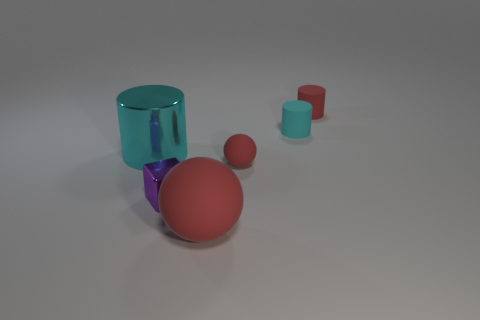There is a big thing that is behind the small rubber sphere; what color is it?
Provide a short and direct response. Cyan. What number of green objects are matte things or large metal things?
Keep it short and to the point. 0. What is the color of the big cylinder?
Your response must be concise. Cyan. Is there anything else that has the same material as the small block?
Offer a very short reply. Yes. Is the number of tiny matte objects that are in front of the big matte object less than the number of cyan matte objects in front of the small rubber ball?
Your response must be concise. No. There is a rubber thing that is on the left side of the small red rubber cylinder and behind the cyan metallic cylinder; what is its shape?
Your answer should be compact. Cylinder. How many big red objects are the same shape as the cyan matte object?
Make the answer very short. 0. The cylinder that is made of the same material as the tiny cube is what size?
Make the answer very short. Large. How many purple cubes have the same size as the cyan metal thing?
Provide a short and direct response. 0. There is a cylinder that is the same color as the small rubber sphere; what is its size?
Offer a terse response. Small. 